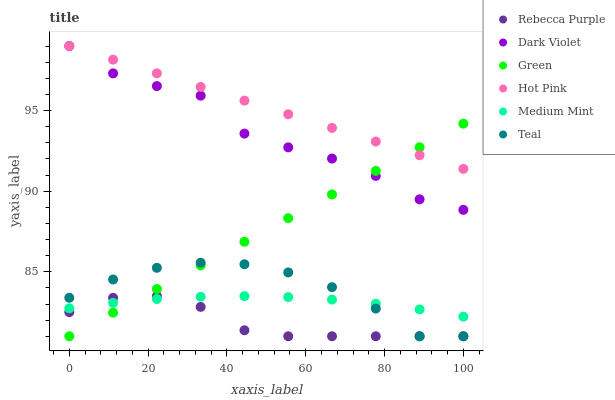Does Rebecca Purple have the minimum area under the curve?
Answer yes or no. Yes. Does Hot Pink have the maximum area under the curve?
Answer yes or no. Yes. Does Dark Violet have the minimum area under the curve?
Answer yes or no. No. Does Dark Violet have the maximum area under the curve?
Answer yes or no. No. Is Green the smoothest?
Answer yes or no. Yes. Is Dark Violet the roughest?
Answer yes or no. Yes. Is Hot Pink the smoothest?
Answer yes or no. No. Is Hot Pink the roughest?
Answer yes or no. No. Does Green have the lowest value?
Answer yes or no. Yes. Does Dark Violet have the lowest value?
Answer yes or no. No. Does Dark Violet have the highest value?
Answer yes or no. Yes. Does Green have the highest value?
Answer yes or no. No. Is Medium Mint less than Hot Pink?
Answer yes or no. Yes. Is Hot Pink greater than Teal?
Answer yes or no. Yes. Does Hot Pink intersect Dark Violet?
Answer yes or no. Yes. Is Hot Pink less than Dark Violet?
Answer yes or no. No. Is Hot Pink greater than Dark Violet?
Answer yes or no. No. Does Medium Mint intersect Hot Pink?
Answer yes or no. No. 